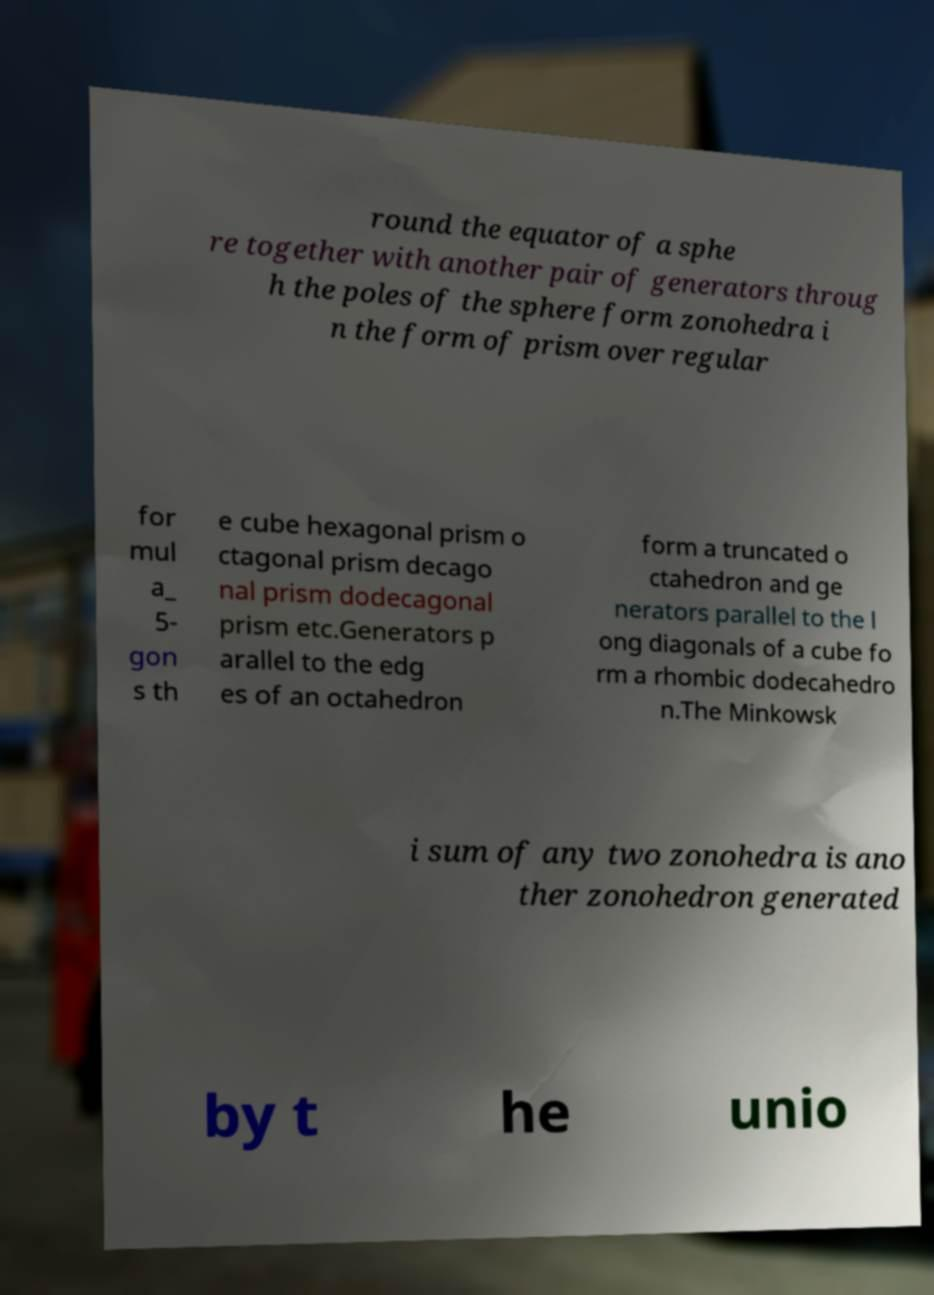Please read and relay the text visible in this image. What does it say? round the equator of a sphe re together with another pair of generators throug h the poles of the sphere form zonohedra i n the form of prism over regular for mul a_ 5- gon s th e cube hexagonal prism o ctagonal prism decago nal prism dodecagonal prism etc.Generators p arallel to the edg es of an octahedron form a truncated o ctahedron and ge nerators parallel to the l ong diagonals of a cube fo rm a rhombic dodecahedro n.The Minkowsk i sum of any two zonohedra is ano ther zonohedron generated by t he unio 